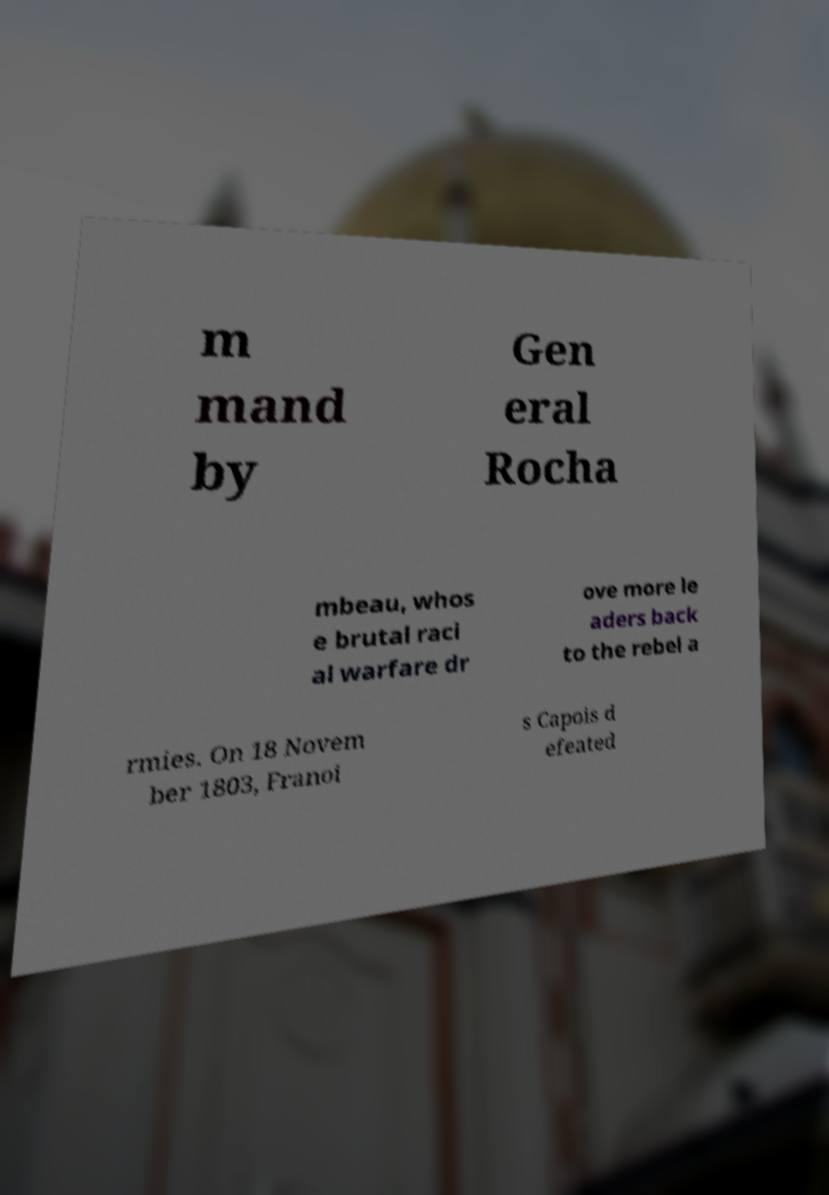Could you assist in decoding the text presented in this image and type it out clearly? m mand by Gen eral Rocha mbeau, whos e brutal raci al warfare dr ove more le aders back to the rebel a rmies. On 18 Novem ber 1803, Franoi s Capois d efeated 